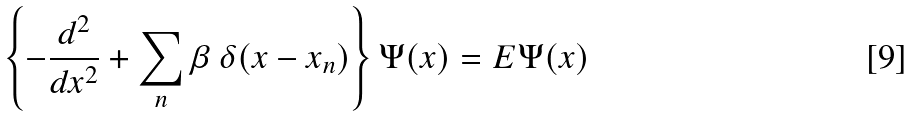<formula> <loc_0><loc_0><loc_500><loc_500>\left \{ - \frac { d ^ { 2 } } { d x ^ { 2 } } + \sum _ { n } \beta \text { } \delta ( x - x _ { n } ) \right \} \Psi ( x ) = E \Psi ( x )</formula> 